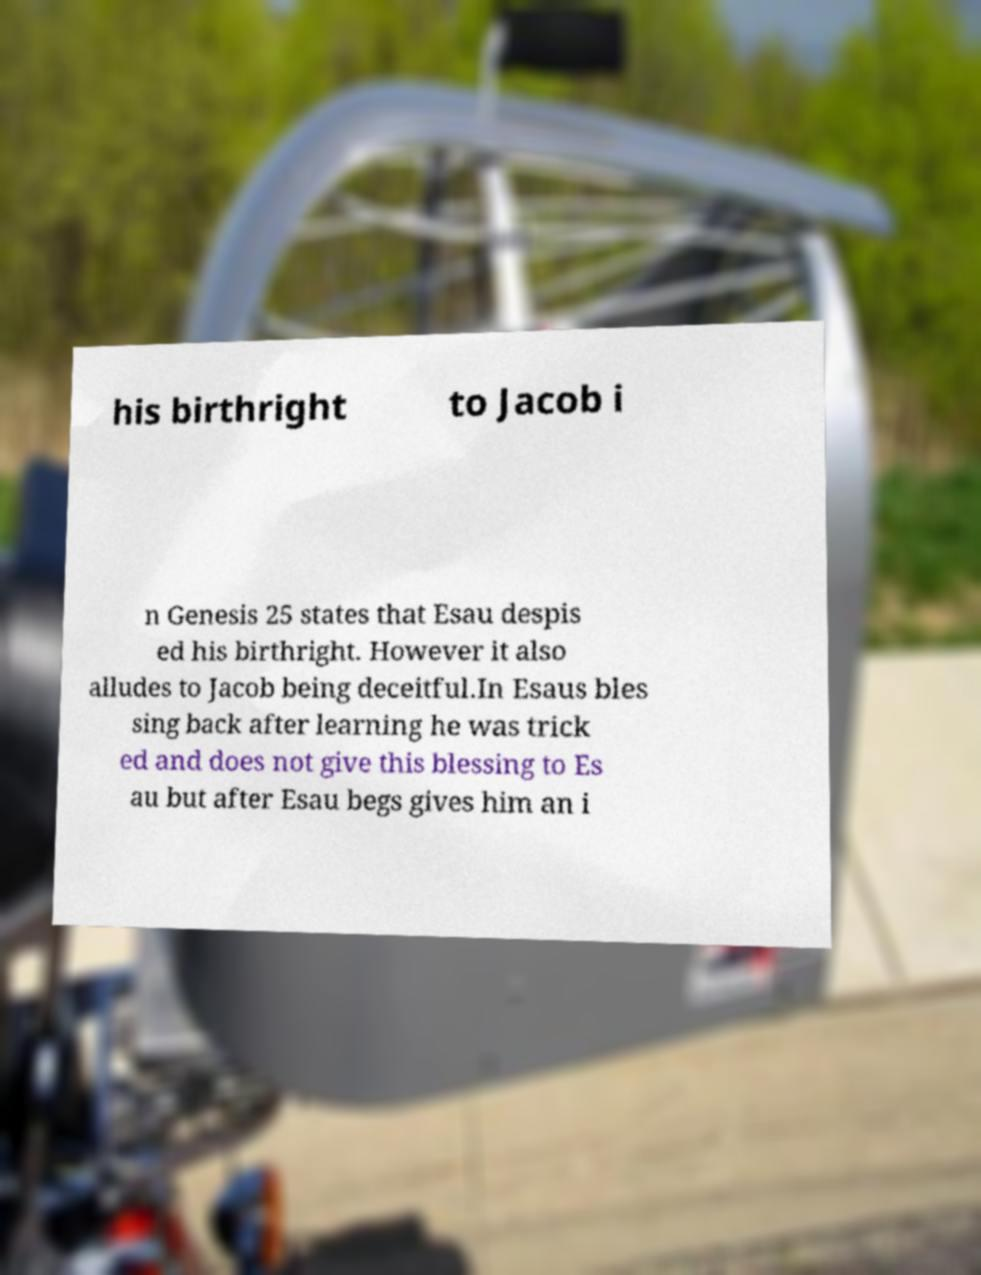Could you assist in decoding the text presented in this image and type it out clearly? his birthright to Jacob i n Genesis 25 states that Esau despis ed his birthright. However it also alludes to Jacob being deceitful.In Esaus bles sing back after learning he was trick ed and does not give this blessing to Es au but after Esau begs gives him an i 